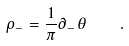<formula> <loc_0><loc_0><loc_500><loc_500>\rho _ { - } = \frac { 1 } { \pi } \partial _ { - } \theta \quad .</formula> 